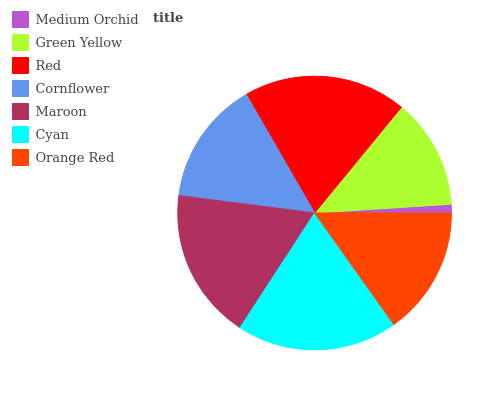Is Medium Orchid the minimum?
Answer yes or no. Yes. Is Red the maximum?
Answer yes or no. Yes. Is Green Yellow the minimum?
Answer yes or no. No. Is Green Yellow the maximum?
Answer yes or no. No. Is Green Yellow greater than Medium Orchid?
Answer yes or no. Yes. Is Medium Orchid less than Green Yellow?
Answer yes or no. Yes. Is Medium Orchid greater than Green Yellow?
Answer yes or no. No. Is Green Yellow less than Medium Orchid?
Answer yes or no. No. Is Orange Red the high median?
Answer yes or no. Yes. Is Orange Red the low median?
Answer yes or no. Yes. Is Cornflower the high median?
Answer yes or no. No. Is Cyan the low median?
Answer yes or no. No. 